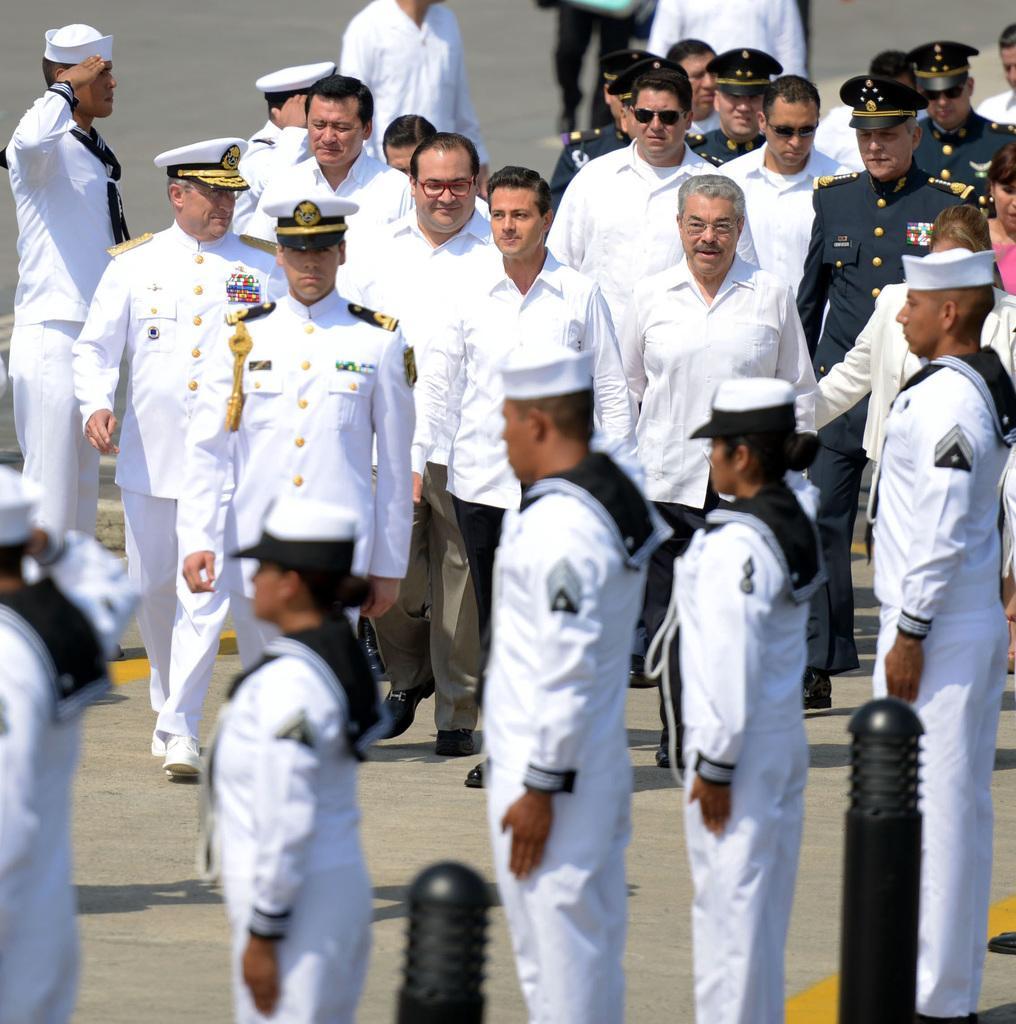Please provide a concise description of this image. This picture describes about group of people, few are standing and few are walking, and we can see few people wore white color clothes, beside to them we can find metal rods. 